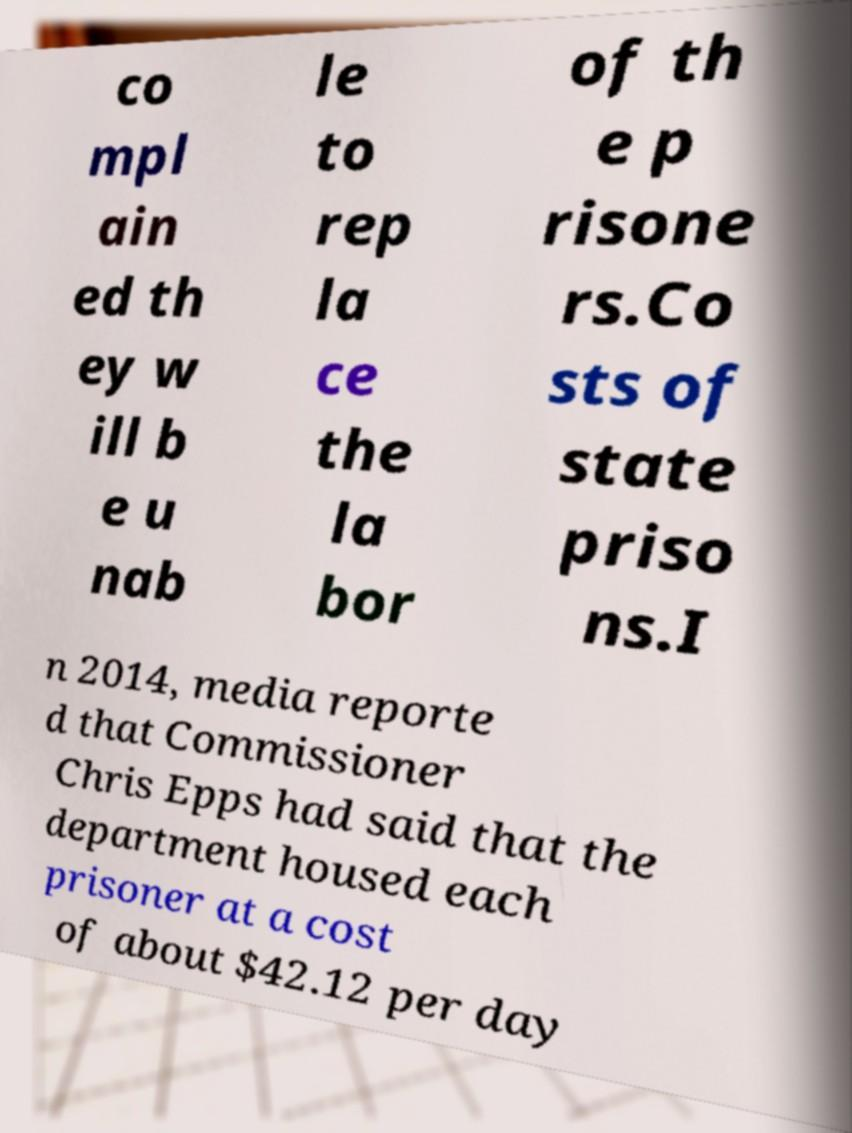Can you accurately transcribe the text from the provided image for me? co mpl ain ed th ey w ill b e u nab le to rep la ce the la bor of th e p risone rs.Co sts of state priso ns.I n 2014, media reporte d that Commissioner Chris Epps had said that the department housed each prisoner at a cost of about $42.12 per day 